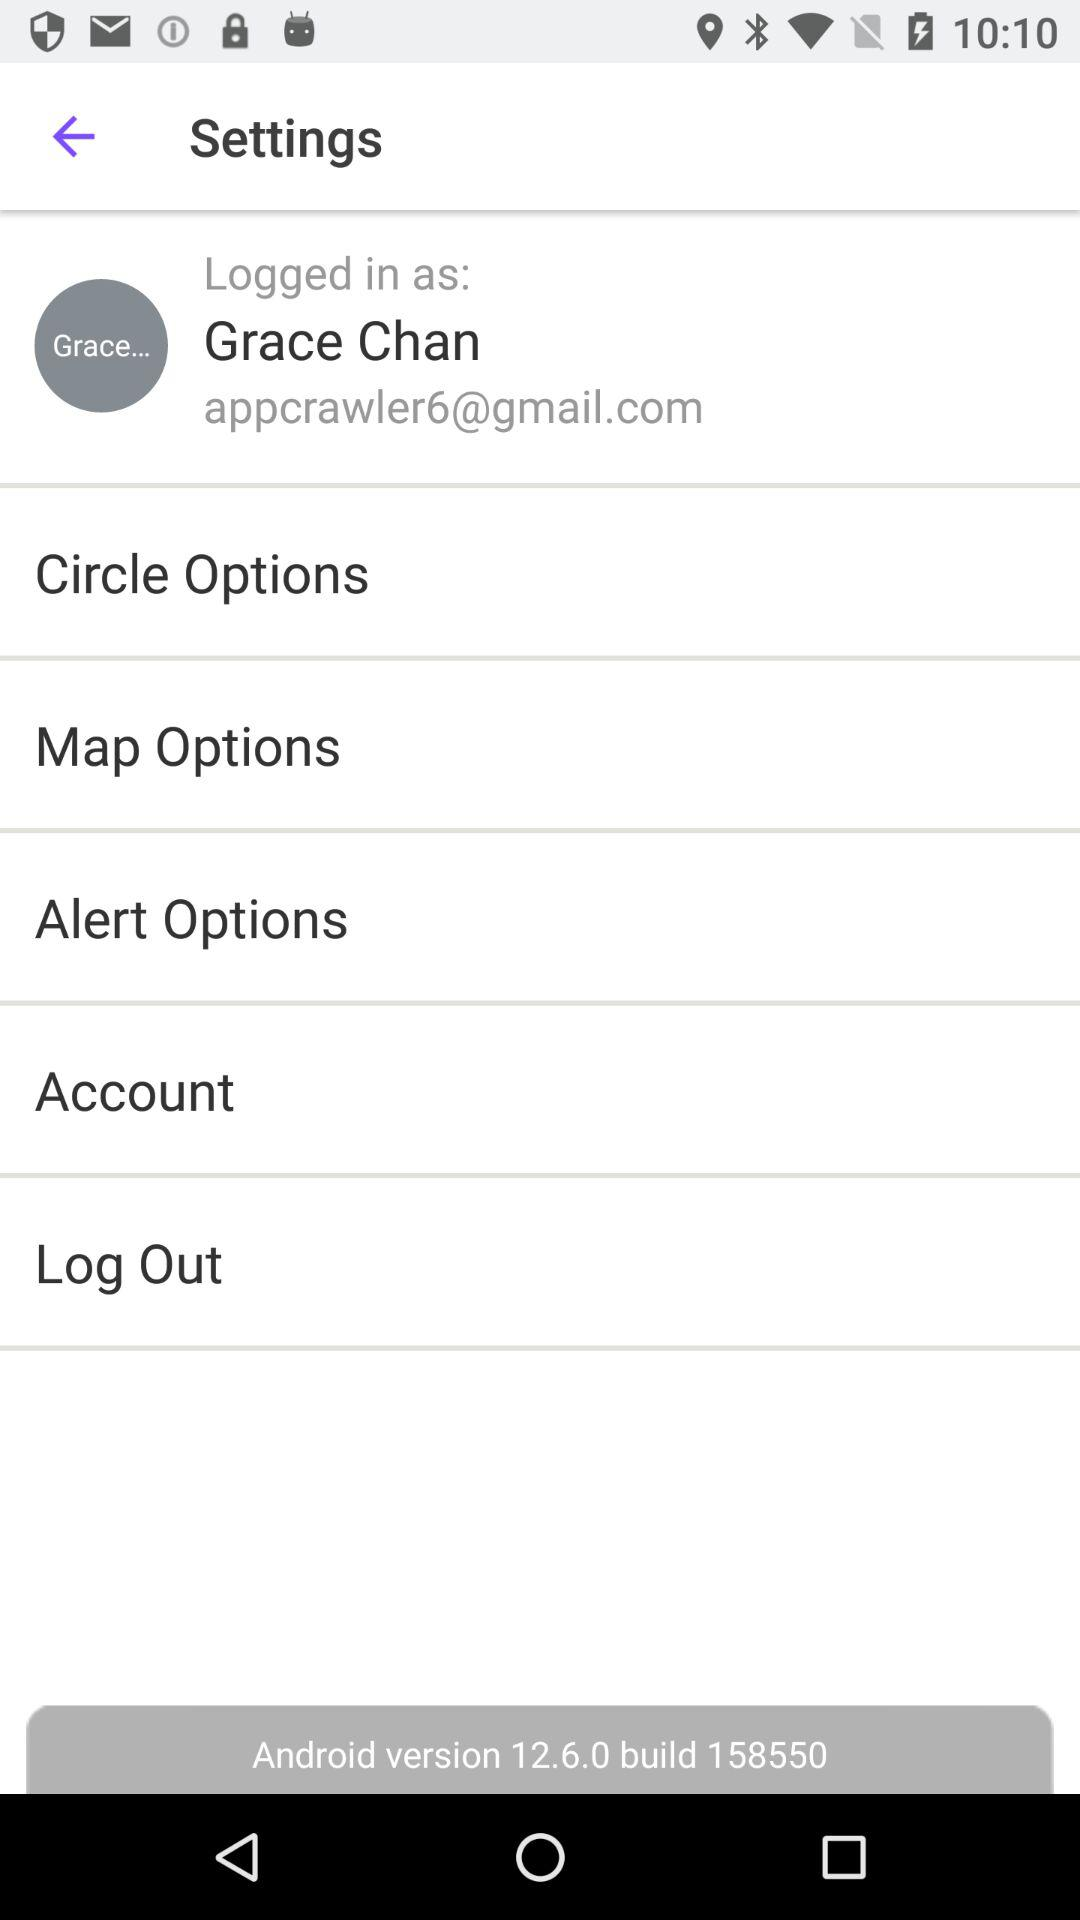What is the name of the user? The name of the user is Grace Chan. 